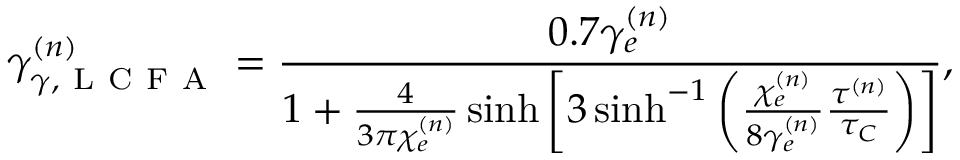<formula> <loc_0><loc_0><loc_500><loc_500>\gamma _ { \gamma , L C F A } ^ { ( n ) } = \frac { 0 . 7 \gamma _ { e } ^ { ( n ) } } { 1 + \frac { 4 } { 3 \pi \chi _ { e } ^ { ( n ) } } \sinh \left [ 3 \sinh ^ { - 1 } \left ( \frac { \chi _ { e } ^ { ( n ) } } { 8 \gamma _ { e } ^ { ( n ) } } \frac { \tau ^ { ( n ) } } { \tau _ { C } } \right ) \right ] } ,</formula> 